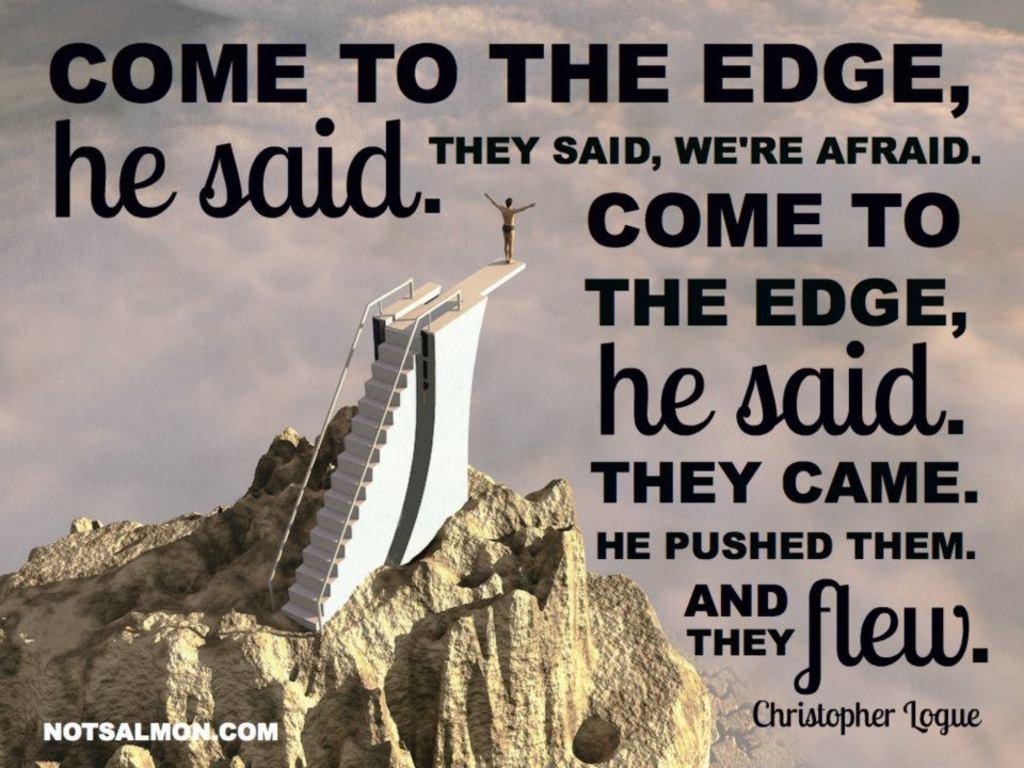Did he say jump from the ledge?
Give a very brief answer. No. What is the url of the add?
Give a very brief answer. Notsalmon.com. 